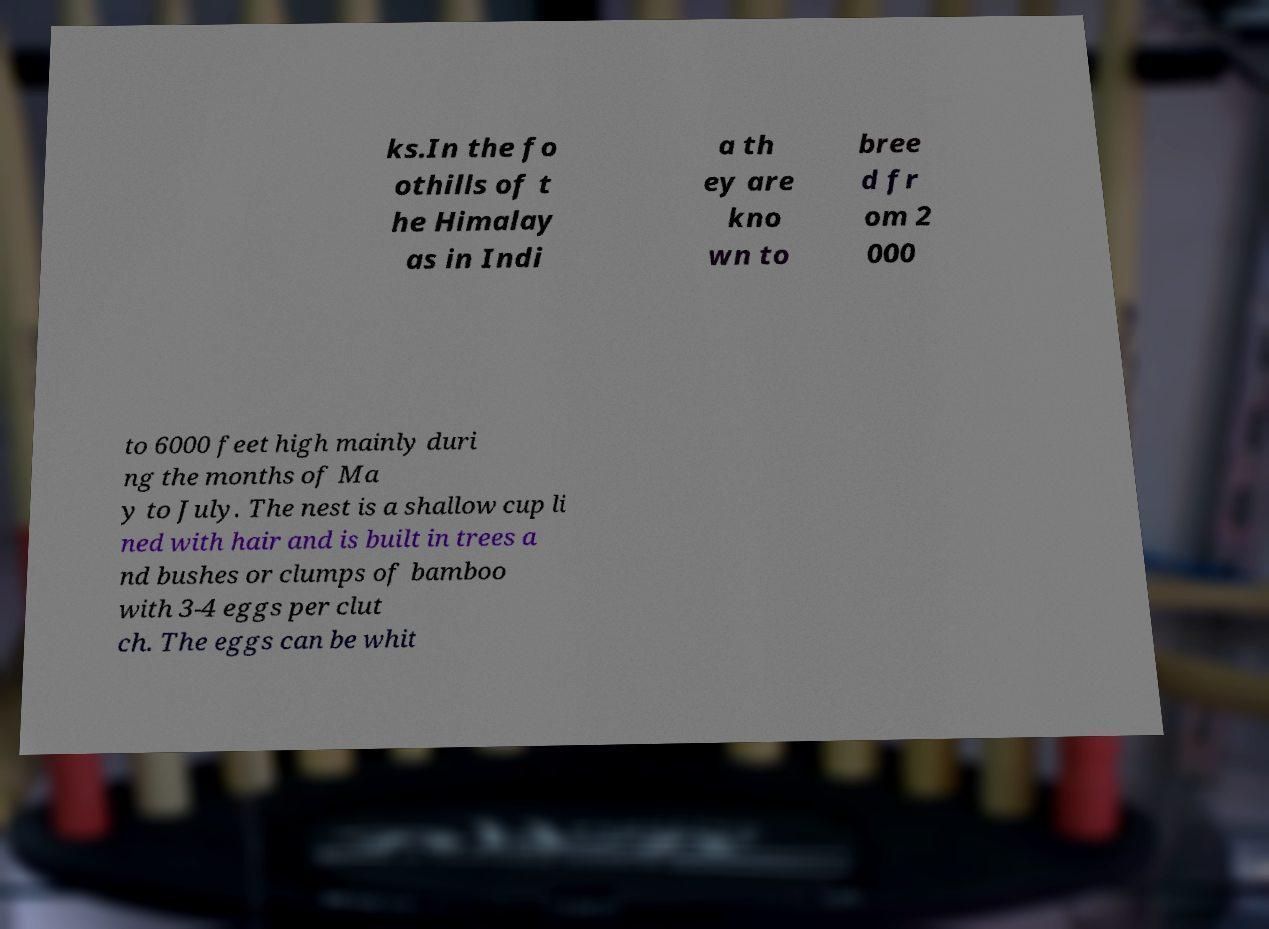Could you assist in decoding the text presented in this image and type it out clearly? ks.In the fo othills of t he Himalay as in Indi a th ey are kno wn to bree d fr om 2 000 to 6000 feet high mainly duri ng the months of Ma y to July. The nest is a shallow cup li ned with hair and is built in trees a nd bushes or clumps of bamboo with 3-4 eggs per clut ch. The eggs can be whit 